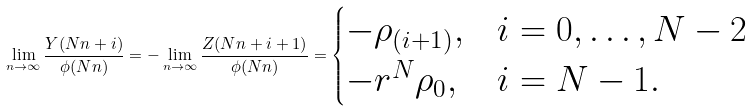<formula> <loc_0><loc_0><loc_500><loc_500>\lim _ { n \to \infty } \frac { Y ( N n + i ) } { \phi ( N n ) } = - \lim _ { n \to \infty } \frac { Z ( N n + i + 1 ) } { \phi ( N n ) } = \begin{cases} - \rho _ { ( i + 1 ) } , & i = 0 , \dots , N - 2 \\ - r ^ { N } \rho _ { 0 } , & i = N - 1 . \end{cases}</formula> 